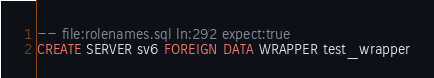<code> <loc_0><loc_0><loc_500><loc_500><_SQL_>-- file:rolenames.sql ln:292 expect:true
CREATE SERVER sv6 FOREIGN DATA WRAPPER test_wrapper
</code> 